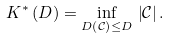<formula> <loc_0><loc_0><loc_500><loc_500>K ^ { * } \left ( D \right ) = \underset { D \left ( \mathcal { C } \right ) \leq D } { \inf } \, \left | \mathcal { C } \right | .</formula> 